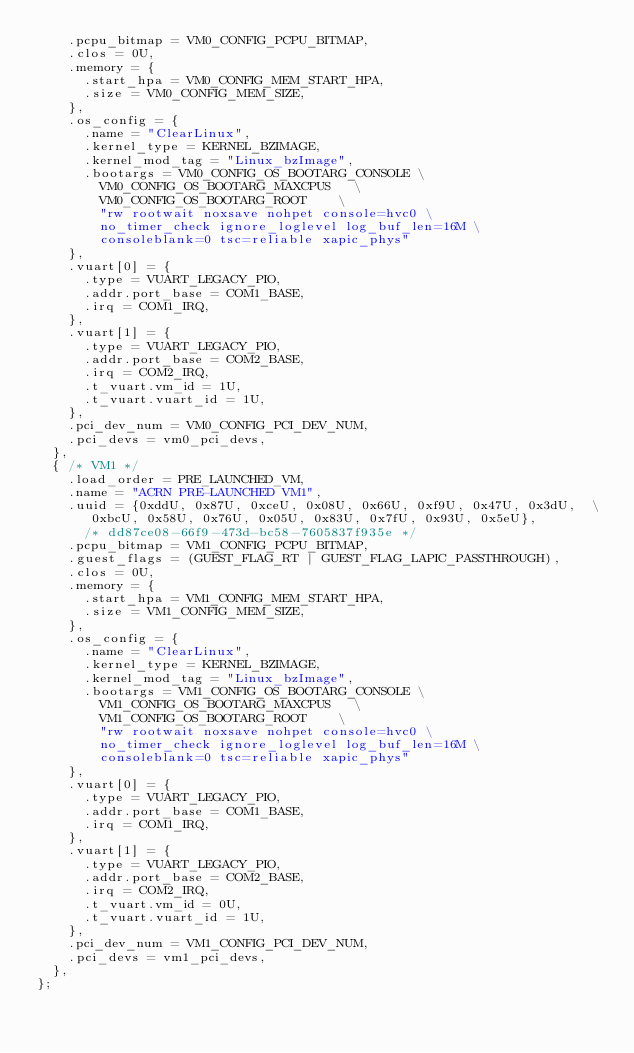<code> <loc_0><loc_0><loc_500><loc_500><_C_>		.pcpu_bitmap = VM0_CONFIG_PCPU_BITMAP,
		.clos = 0U,
		.memory = {
			.start_hpa = VM0_CONFIG_MEM_START_HPA,
			.size = VM0_CONFIG_MEM_SIZE,
		},
		.os_config = {
			.name = "ClearLinux",
			.kernel_type = KERNEL_BZIMAGE,
			.kernel_mod_tag = "Linux_bzImage",
			.bootargs = VM0_CONFIG_OS_BOOTARG_CONSOLE	\
				VM0_CONFIG_OS_BOOTARG_MAXCPUS		\
				VM0_CONFIG_OS_BOOTARG_ROOT		\
				"rw rootwait noxsave nohpet console=hvc0 \
				no_timer_check ignore_loglevel log_buf_len=16M \
				consoleblank=0 tsc=reliable xapic_phys"
		},
		.vuart[0] = {
			.type = VUART_LEGACY_PIO,
			.addr.port_base = COM1_BASE,
			.irq = COM1_IRQ,
		},
		.vuart[1] = {
			.type = VUART_LEGACY_PIO,
			.addr.port_base = COM2_BASE,
			.irq = COM2_IRQ,
			.t_vuart.vm_id = 1U,
			.t_vuart.vuart_id = 1U,
		},
		.pci_dev_num = VM0_CONFIG_PCI_DEV_NUM,
		.pci_devs = vm0_pci_devs,
	},
	{	/* VM1 */
		.load_order = PRE_LAUNCHED_VM,
		.name = "ACRN PRE-LAUNCHED VM1",
		.uuid = {0xddU, 0x87U, 0xceU, 0x08U, 0x66U, 0xf9U, 0x47U, 0x3dU,	\
			 0xbcU, 0x58U, 0x76U, 0x05U, 0x83U, 0x7fU, 0x93U, 0x5eU},
			/* dd87ce08-66f9-473d-bc58-7605837f935e */
		.pcpu_bitmap = VM1_CONFIG_PCPU_BITMAP,
		.guest_flags = (GUEST_FLAG_RT | GUEST_FLAG_LAPIC_PASSTHROUGH),
		.clos = 0U,
		.memory = {
			.start_hpa = VM1_CONFIG_MEM_START_HPA,
			.size = VM1_CONFIG_MEM_SIZE,
		},
		.os_config = {
			.name = "ClearLinux",
			.kernel_type = KERNEL_BZIMAGE,
			.kernel_mod_tag = "Linux_bzImage",
			.bootargs = VM1_CONFIG_OS_BOOTARG_CONSOLE	\
				VM1_CONFIG_OS_BOOTARG_MAXCPUS		\
				VM1_CONFIG_OS_BOOTARG_ROOT		\
				"rw rootwait noxsave nohpet console=hvc0 \
				no_timer_check ignore_loglevel log_buf_len=16M \
				consoleblank=0 tsc=reliable xapic_phys"
		},
		.vuart[0] = {
			.type = VUART_LEGACY_PIO,
			.addr.port_base = COM1_BASE,
			.irq = COM1_IRQ,
		},
		.vuart[1] = {
			.type = VUART_LEGACY_PIO,
			.addr.port_base = COM2_BASE,
			.irq = COM2_IRQ,
			.t_vuart.vm_id = 0U,
			.t_vuart.vuart_id = 1U,
		},
		.pci_dev_num = VM1_CONFIG_PCI_DEV_NUM,
		.pci_devs = vm1_pci_devs,
	},
};
</code> 